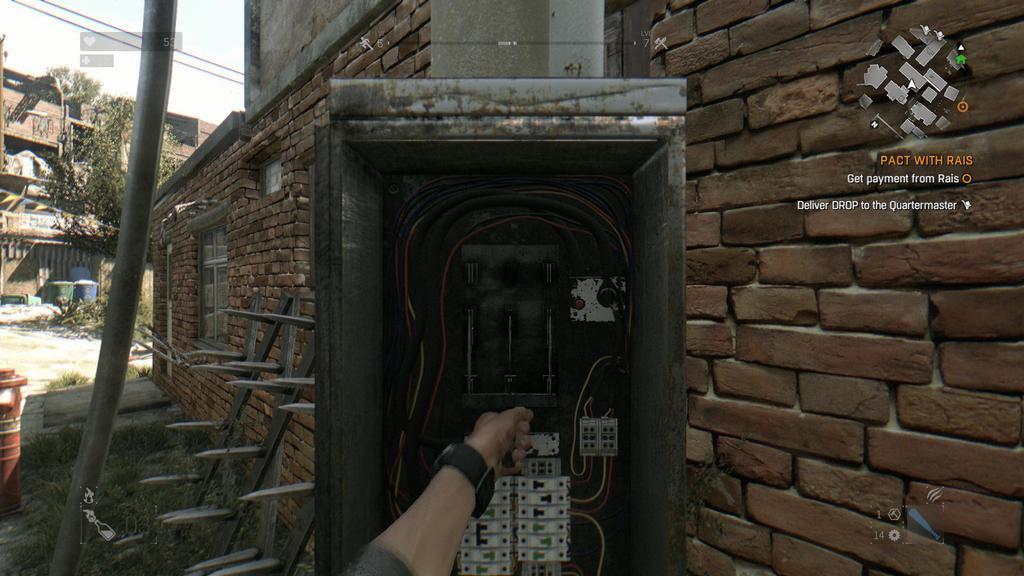Could you give a brief overview of what you see in this image? In this image I can see an electric circuit and I can also see a person hand. Background I can see few buildings in brown color, trees in green color, a pole and the sky is in white color. 